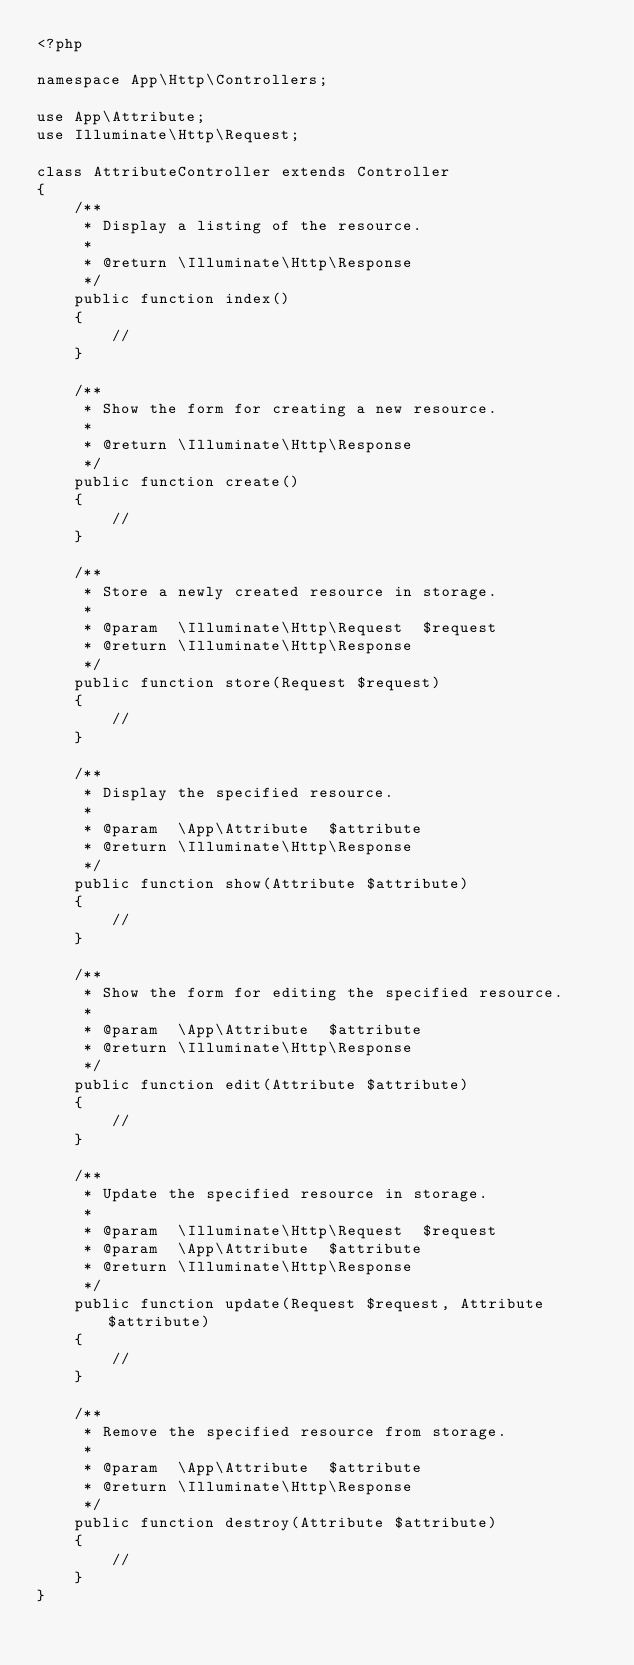<code> <loc_0><loc_0><loc_500><loc_500><_PHP_><?php

namespace App\Http\Controllers;

use App\Attribute;
use Illuminate\Http\Request;

class AttributeController extends Controller
{
    /**
     * Display a listing of the resource.
     *
     * @return \Illuminate\Http\Response
     */
    public function index()
    {
        //
    }

    /**
     * Show the form for creating a new resource.
     *
     * @return \Illuminate\Http\Response
     */
    public function create()
    {
        //
    }

    /**
     * Store a newly created resource in storage.
     *
     * @param  \Illuminate\Http\Request  $request
     * @return \Illuminate\Http\Response
     */
    public function store(Request $request)
    {
        //
    }

    /**
     * Display the specified resource.
     *
     * @param  \App\Attribute  $attribute
     * @return \Illuminate\Http\Response
     */
    public function show(Attribute $attribute)
    {
        //
    }

    /**
     * Show the form for editing the specified resource.
     *
     * @param  \App\Attribute  $attribute
     * @return \Illuminate\Http\Response
     */
    public function edit(Attribute $attribute)
    {
        //
    }

    /**
     * Update the specified resource in storage.
     *
     * @param  \Illuminate\Http\Request  $request
     * @param  \App\Attribute  $attribute
     * @return \Illuminate\Http\Response
     */
    public function update(Request $request, Attribute $attribute)
    {
        //
    }

    /**
     * Remove the specified resource from storage.
     *
     * @param  \App\Attribute  $attribute
     * @return \Illuminate\Http\Response
     */
    public function destroy(Attribute $attribute)
    {
        //
    }
}
</code> 